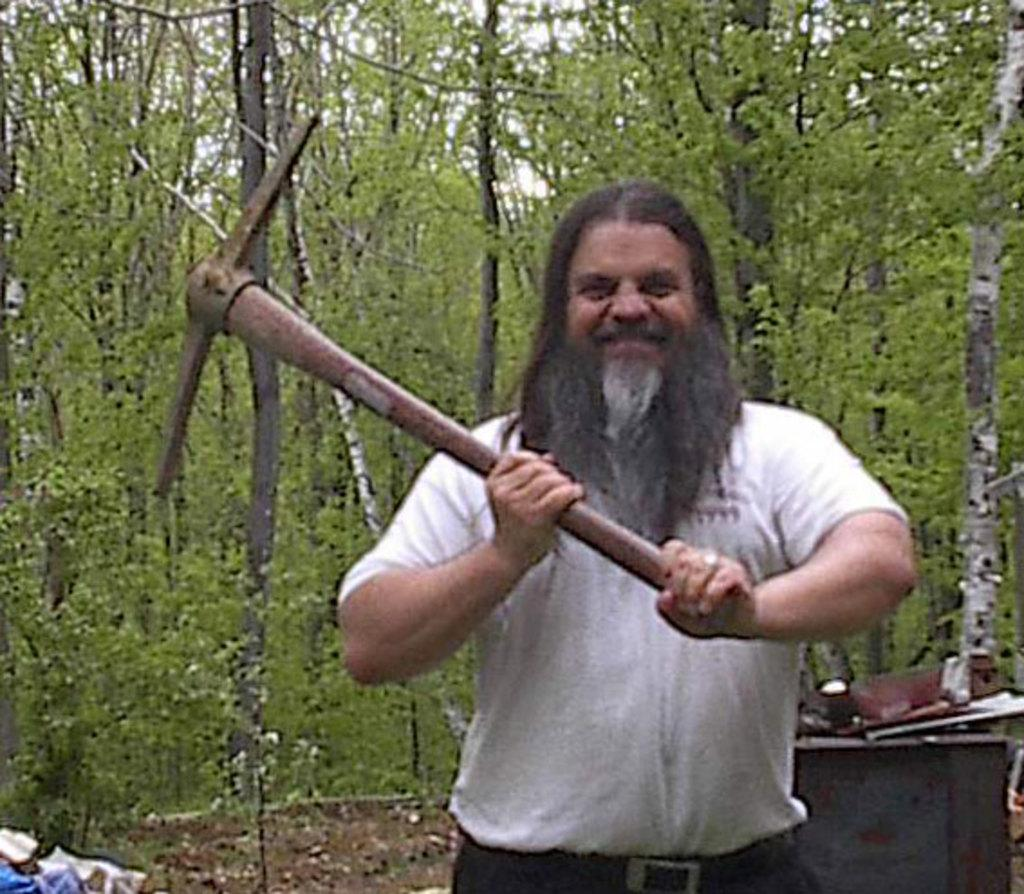Who is the main subject in the image? There is a man in the center of the image. What is the man holding in the image? The man is holding an axe. What else can be seen in the background of the image? There are other tools and trees in the background of the image. What color is the scarf worn by the parent in the image? There is no parent or scarf present in the image. 